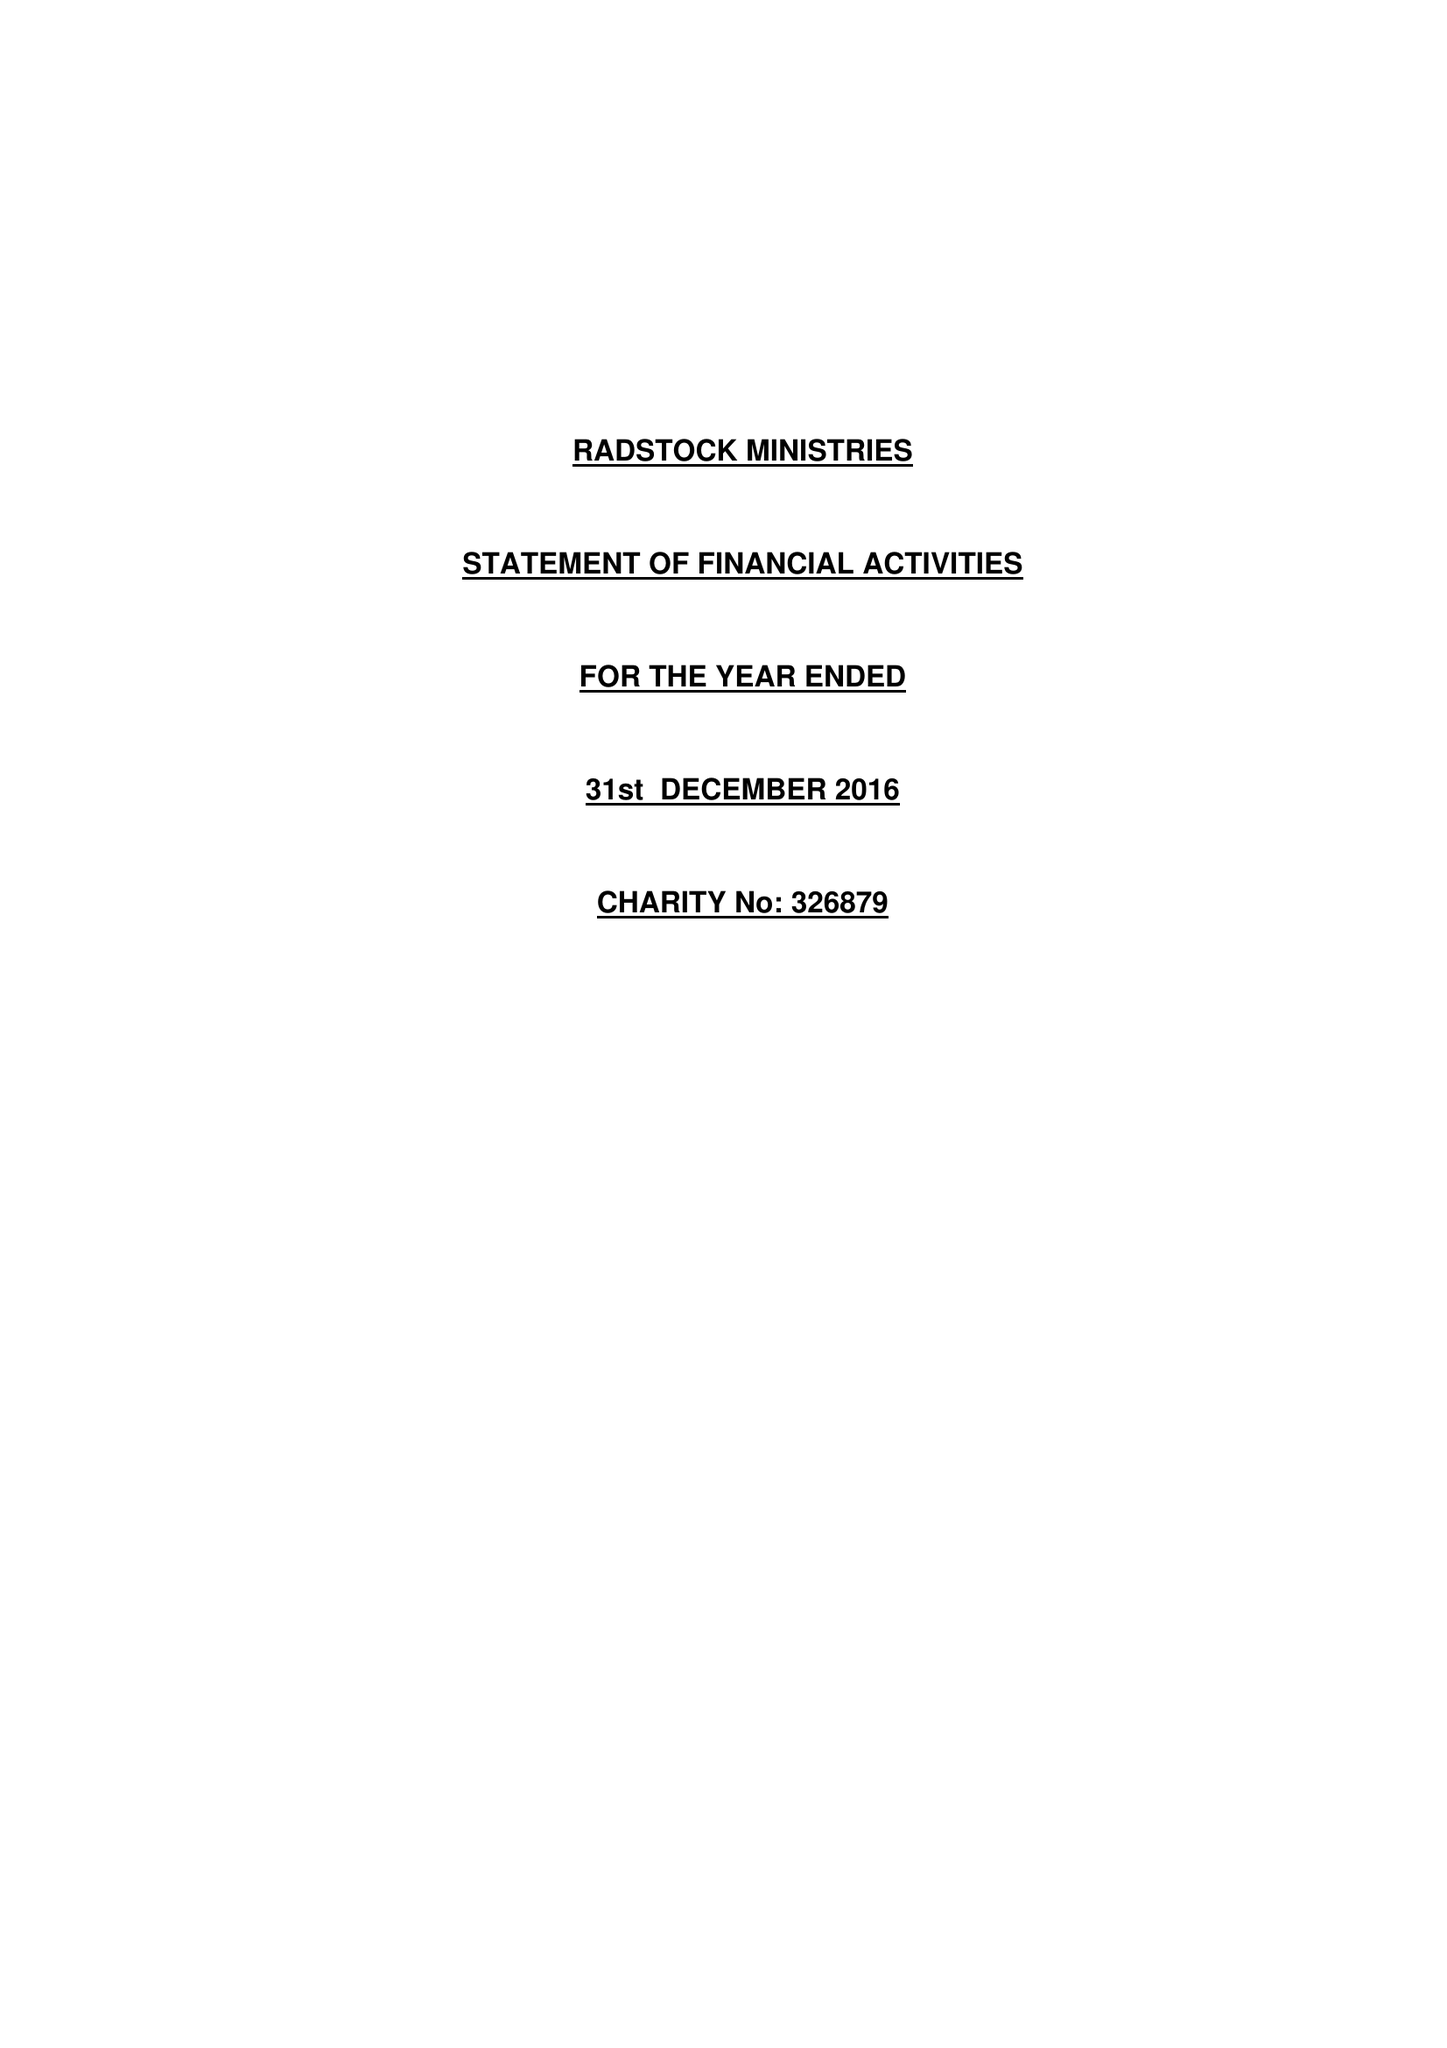What is the value for the charity_number?
Answer the question using a single word or phrase. 326879 